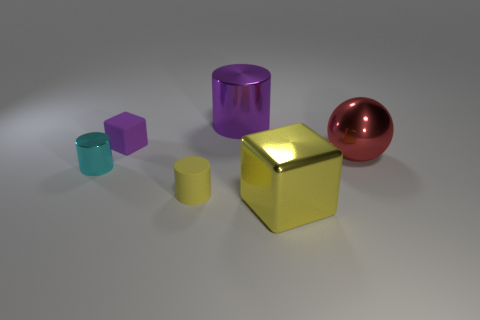Subtract all shiny cylinders. How many cylinders are left? 1 Subtract 1 cylinders. How many cylinders are left? 2 Add 2 tiny cyan metallic spheres. How many objects exist? 8 Subtract all spheres. How many objects are left? 5 Subtract all gray cylinders. Subtract all red spheres. How many cylinders are left? 3 Add 3 large red objects. How many large red objects exist? 4 Subtract 0 green cylinders. How many objects are left? 6 Subtract all small yellow shiny cubes. Subtract all tiny cylinders. How many objects are left? 4 Add 3 big cylinders. How many big cylinders are left? 4 